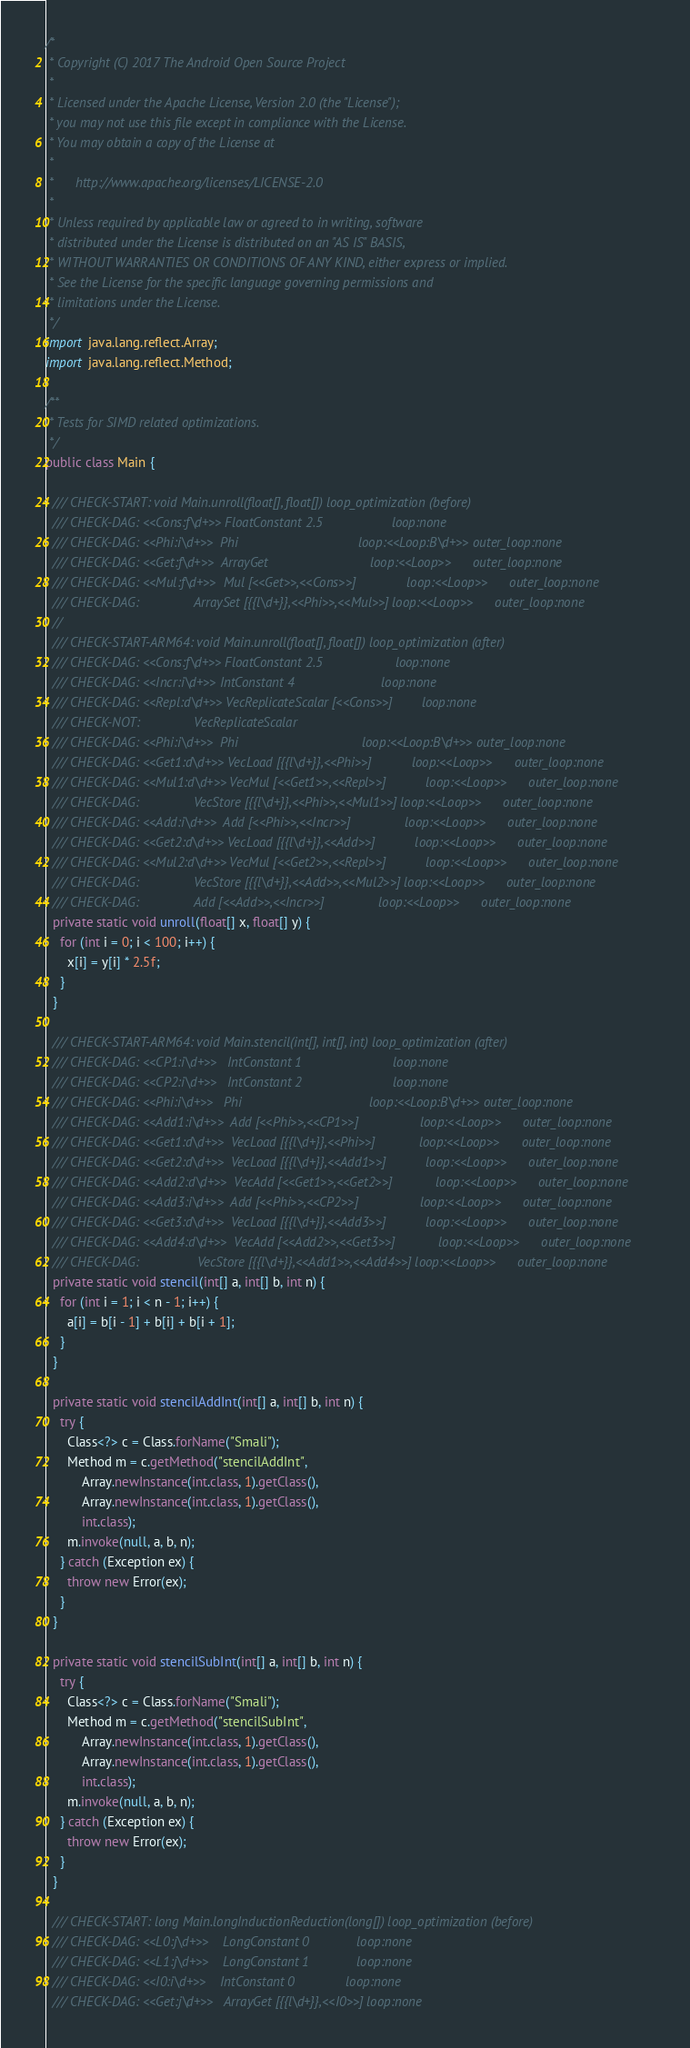Convert code to text. <code><loc_0><loc_0><loc_500><loc_500><_Java_>/*
 * Copyright (C) 2017 The Android Open Source Project
 *
 * Licensed under the Apache License, Version 2.0 (the "License");
 * you may not use this file except in compliance with the License.
 * You may obtain a copy of the License at
 *
 *      http://www.apache.org/licenses/LICENSE-2.0
 *
 * Unless required by applicable law or agreed to in writing, software
 * distributed under the License is distributed on an "AS IS" BASIS,
 * WITHOUT WARRANTIES OR CONDITIONS OF ANY KIND, either express or implied.
 * See the License for the specific language governing permissions and
 * limitations under the License.
 */
import java.lang.reflect.Array;
import java.lang.reflect.Method;

/**
 * Tests for SIMD related optimizations.
 */
public class Main {

  /// CHECK-START: void Main.unroll(float[], float[]) loop_optimization (before)
  /// CHECK-DAG: <<Cons:f\d+>> FloatConstant 2.5                   loop:none
  /// CHECK-DAG: <<Phi:i\d+>>  Phi                                 loop:<<Loop:B\d+>> outer_loop:none
  /// CHECK-DAG: <<Get:f\d+>>  ArrayGet                            loop:<<Loop>>      outer_loop:none
  /// CHECK-DAG: <<Mul:f\d+>>  Mul [<<Get>>,<<Cons>>]              loop:<<Loop>>      outer_loop:none
  /// CHECK-DAG:               ArraySet [{{l\d+}},<<Phi>>,<<Mul>>] loop:<<Loop>>      outer_loop:none
  //
  /// CHECK-START-ARM64: void Main.unroll(float[], float[]) loop_optimization (after)
  /// CHECK-DAG: <<Cons:f\d+>> FloatConstant 2.5                    loop:none
  /// CHECK-DAG: <<Incr:i\d+>> IntConstant 4                        loop:none
  /// CHECK-DAG: <<Repl:d\d+>> VecReplicateScalar [<<Cons>>]        loop:none
  /// CHECK-NOT:               VecReplicateScalar
  /// CHECK-DAG: <<Phi:i\d+>>  Phi                                  loop:<<Loop:B\d+>> outer_loop:none
  /// CHECK-DAG: <<Get1:d\d+>> VecLoad [{{l\d+}},<<Phi>>]           loop:<<Loop>>      outer_loop:none
  /// CHECK-DAG: <<Mul1:d\d+>> VecMul [<<Get1>>,<<Repl>>]           loop:<<Loop>>      outer_loop:none
  /// CHECK-DAG:               VecStore [{{l\d+}},<<Phi>>,<<Mul1>>] loop:<<Loop>>      outer_loop:none
  /// CHECK-DAG: <<Add:i\d+>>  Add [<<Phi>>,<<Incr>>]               loop:<<Loop>>      outer_loop:none
  /// CHECK-DAG: <<Get2:d\d+>> VecLoad [{{l\d+}},<<Add>>]           loop:<<Loop>>      outer_loop:none
  /// CHECK-DAG: <<Mul2:d\d+>> VecMul [<<Get2>>,<<Repl>>]           loop:<<Loop>>      outer_loop:none
  /// CHECK-DAG:               VecStore [{{l\d+}},<<Add>>,<<Mul2>>] loop:<<Loop>>      outer_loop:none
  /// CHECK-DAG:               Add [<<Add>>,<<Incr>>]               loop:<<Loop>>      outer_loop:none
  private static void unroll(float[] x, float[] y) {
    for (int i = 0; i < 100; i++) {
      x[i] = y[i] * 2.5f;
    }
  }

  /// CHECK-START-ARM64: void Main.stencil(int[], int[], int) loop_optimization (after)
  /// CHECK-DAG: <<CP1:i\d+>>   IntConstant 1                         loop:none
  /// CHECK-DAG: <<CP2:i\d+>>   IntConstant 2                         loop:none
  /// CHECK-DAG: <<Phi:i\d+>>   Phi                                   loop:<<Loop:B\d+>> outer_loop:none
  /// CHECK-DAG: <<Add1:i\d+>>  Add [<<Phi>>,<<CP1>>]                 loop:<<Loop>>      outer_loop:none
  /// CHECK-DAG: <<Get1:d\d+>>  VecLoad [{{l\d+}},<<Phi>>]            loop:<<Loop>>      outer_loop:none
  /// CHECK-DAG: <<Get2:d\d+>>  VecLoad [{{l\d+}},<<Add1>>]           loop:<<Loop>>      outer_loop:none
  /// CHECK-DAG: <<Add2:d\d+>>  VecAdd [<<Get1>>,<<Get2>>]            loop:<<Loop>>      outer_loop:none
  /// CHECK-DAG: <<Add3:i\d+>>  Add [<<Phi>>,<<CP2>>]                 loop:<<Loop>>      outer_loop:none
  /// CHECK-DAG: <<Get3:d\d+>>  VecLoad [{{l\d+}},<<Add3>>]           loop:<<Loop>>      outer_loop:none
  /// CHECK-DAG: <<Add4:d\d+>>  VecAdd [<<Add2>>,<<Get3>>]            loop:<<Loop>>      outer_loop:none
  /// CHECK-DAG:                VecStore [{{l\d+}},<<Add1>>,<<Add4>>] loop:<<Loop>>      outer_loop:none
  private static void stencil(int[] a, int[] b, int n) {
    for (int i = 1; i < n - 1; i++) {
      a[i] = b[i - 1] + b[i] + b[i + 1];
    }
  }

  private static void stencilAddInt(int[] a, int[] b, int n) {
    try {
      Class<?> c = Class.forName("Smali");
      Method m = c.getMethod("stencilAddInt",
          Array.newInstance(int.class, 1).getClass(),
          Array.newInstance(int.class, 1).getClass(),
          int.class);
      m.invoke(null, a, b, n);
    } catch (Exception ex) {
      throw new Error(ex);
    }
  }

  private static void stencilSubInt(int[] a, int[] b, int n) {
    try {
      Class<?> c = Class.forName("Smali");
      Method m = c.getMethod("stencilSubInt",
          Array.newInstance(int.class, 1).getClass(),
          Array.newInstance(int.class, 1).getClass(),
          int.class);
      m.invoke(null, a, b, n);
    } catch (Exception ex) {
      throw new Error(ex);
    }
  }

  /// CHECK-START: long Main.longInductionReduction(long[]) loop_optimization (before)
  /// CHECK-DAG: <<L0:j\d+>>    LongConstant 0             loop:none
  /// CHECK-DAG: <<L1:j\d+>>    LongConstant 1             loop:none
  /// CHECK-DAG: <<I0:i\d+>>    IntConstant 0              loop:none
  /// CHECK-DAG: <<Get:j\d+>>   ArrayGet [{{l\d+}},<<I0>>] loop:none</code> 